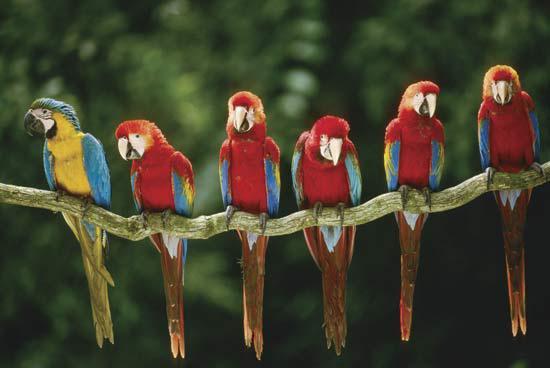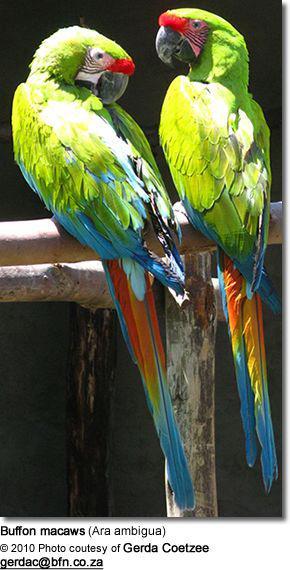The first image is the image on the left, the second image is the image on the right. Considering the images on both sides, is "The right and left images contain the same number of parrots." valid? Answer yes or no. No. The first image is the image on the left, the second image is the image on the right. Considering the images on both sides, is "There are no less than four birds" valid? Answer yes or no. Yes. 